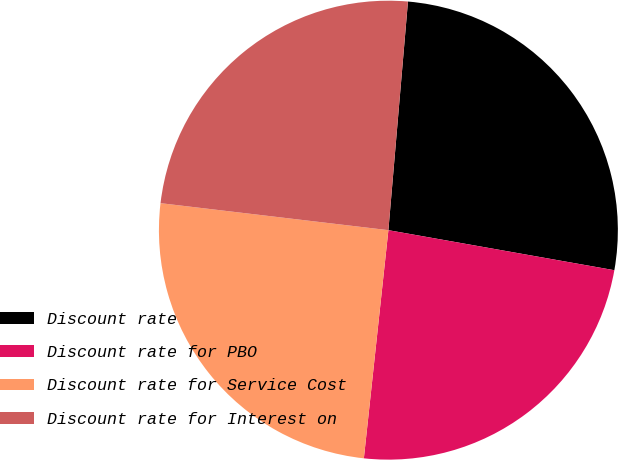Convert chart to OTSL. <chart><loc_0><loc_0><loc_500><loc_500><pie_chart><fcel>Discount rate<fcel>Discount rate for PBO<fcel>Discount rate for Service Cost<fcel>Discount rate for Interest on<nl><fcel>26.43%<fcel>23.91%<fcel>25.17%<fcel>24.48%<nl></chart> 